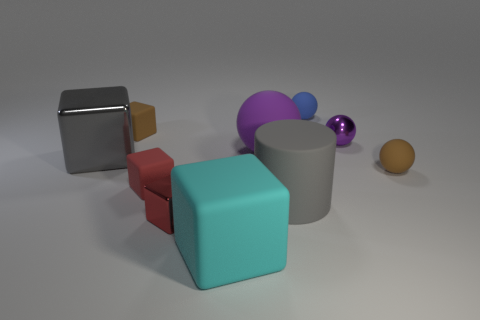Is the material of the tiny purple thing the same as the large cyan thing?
Provide a short and direct response. No. How many balls are big cyan things or gray rubber objects?
Offer a terse response. 0. What is the size of the gray cube that is behind the small shiny thing that is to the left of the purple sphere that is left of the tiny blue object?
Offer a terse response. Large. What size is the gray object that is the same shape as the small red shiny object?
Give a very brief answer. Large. How many big cubes are in front of the large matte cylinder?
Give a very brief answer. 1. Do the small object that is to the right of the small purple ball and the matte cylinder have the same color?
Keep it short and to the point. No. How many blue objects are either large matte cylinders or big metal blocks?
Ensure brevity in your answer.  0. What color is the big matte object behind the small brown matte thing to the right of the small blue rubber object?
Your answer should be very brief. Purple. There is another sphere that is the same color as the metal sphere; what is its material?
Offer a very short reply. Rubber. The tiny cube that is in front of the cylinder is what color?
Offer a terse response. Red. 